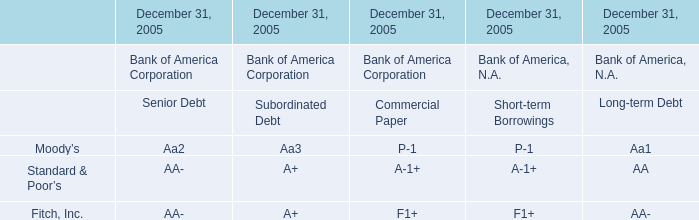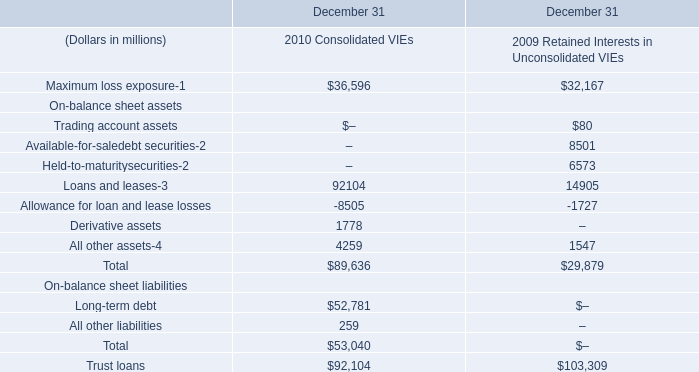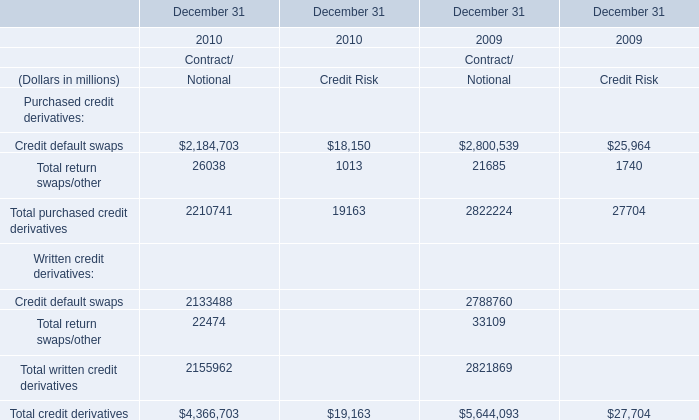What will Credit default swaps of Purchased credit derivatives of Contract/Notional reach in 2011 if it continues to grow at its current rate? (in million) 
Computations: (2184703 * (1 + ((2184703 - 2800539) / 2800539)))
Answer: 1704288.78091. 